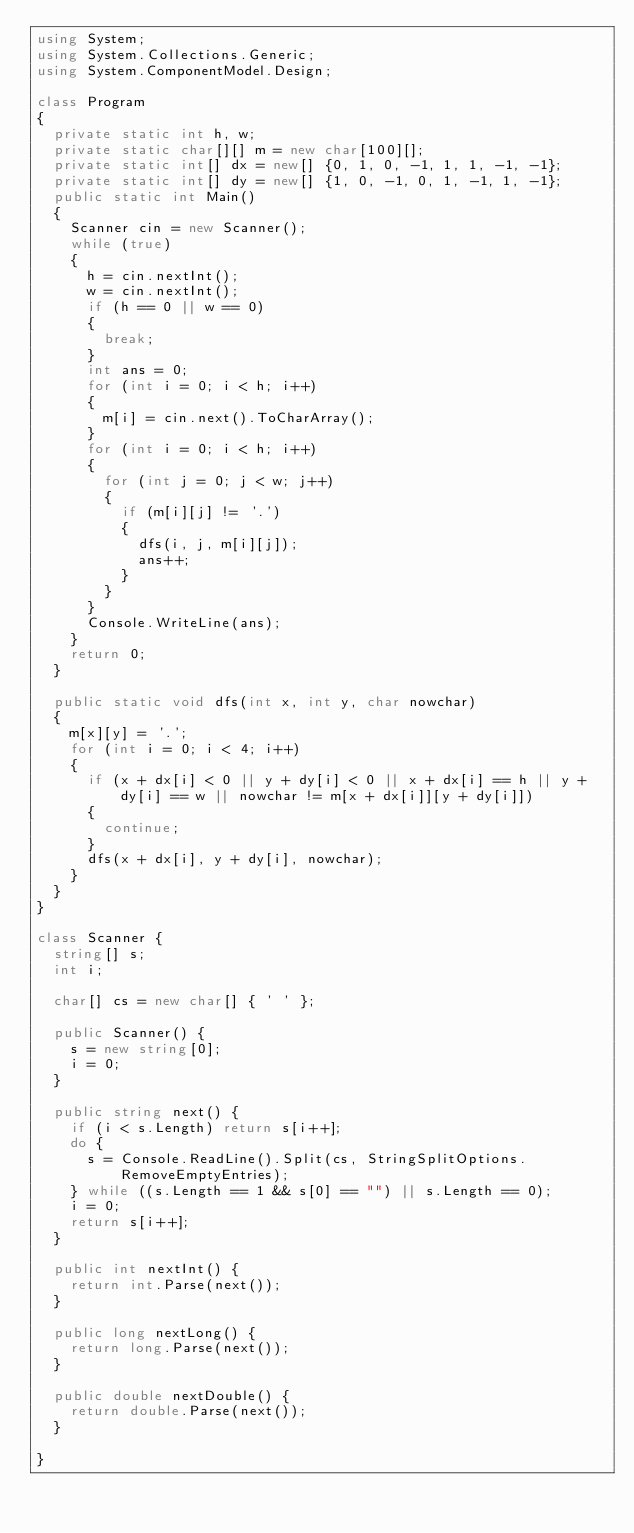Convert code to text. <code><loc_0><loc_0><loc_500><loc_500><_C#_>using System;
using System.Collections.Generic;
using System.ComponentModel.Design;

class Program
{
	private static int h, w;
	private static char[][] m = new char[100][];
	private static int[] dx = new[] {0, 1, 0, -1, 1, 1, -1, -1};
	private static int[] dy = new[] {1, 0, -1, 0, 1, -1, 1, -1};
	public static int Main()
	{
		Scanner cin = new Scanner();
		while (true)
		{
			h = cin.nextInt();
			w = cin.nextInt();
			if (h == 0 || w == 0)
			{
				break;
			}
			int ans = 0;
			for (int i = 0; i < h; i++)
			{
				m[i] = cin.next().ToCharArray();
			}
			for (int i = 0; i < h; i++)
			{
				for (int j = 0; j < w; j++)
				{
					if (m[i][j] != '.')
					{
						dfs(i, j, m[i][j]);
						ans++;
					}
				}
			}
			Console.WriteLine(ans);
		}
		return 0;
	}

	public static void dfs(int x, int y, char nowchar)
	{
		m[x][y] = '.';
		for (int i = 0; i < 4; i++)
		{
			if (x + dx[i] < 0 || y + dy[i] < 0 || x + dx[i] == h || y + dy[i] == w || nowchar != m[x + dx[i]][y + dy[i]])
			{
				continue;
			}
			dfs(x + dx[i], y + dy[i], nowchar);
		}
	}
}

class Scanner {
	string[] s;
	int i;

	char[] cs = new char[] { ' ' };

	public Scanner() {
		s = new string[0];
		i = 0;
	}

	public string next() {
		if (i < s.Length) return s[i++];
		do {
			s = Console.ReadLine().Split(cs, StringSplitOptions.RemoveEmptyEntries);
		} while ((s.Length == 1 && s[0] == "") || s.Length == 0);
		i = 0;
		return s[i++];
	}

	public int nextInt() {
		return int.Parse(next());
	}

	public long nextLong() {
		return long.Parse(next());
	}

	public double nextDouble() {
		return double.Parse(next());
	}

}</code> 